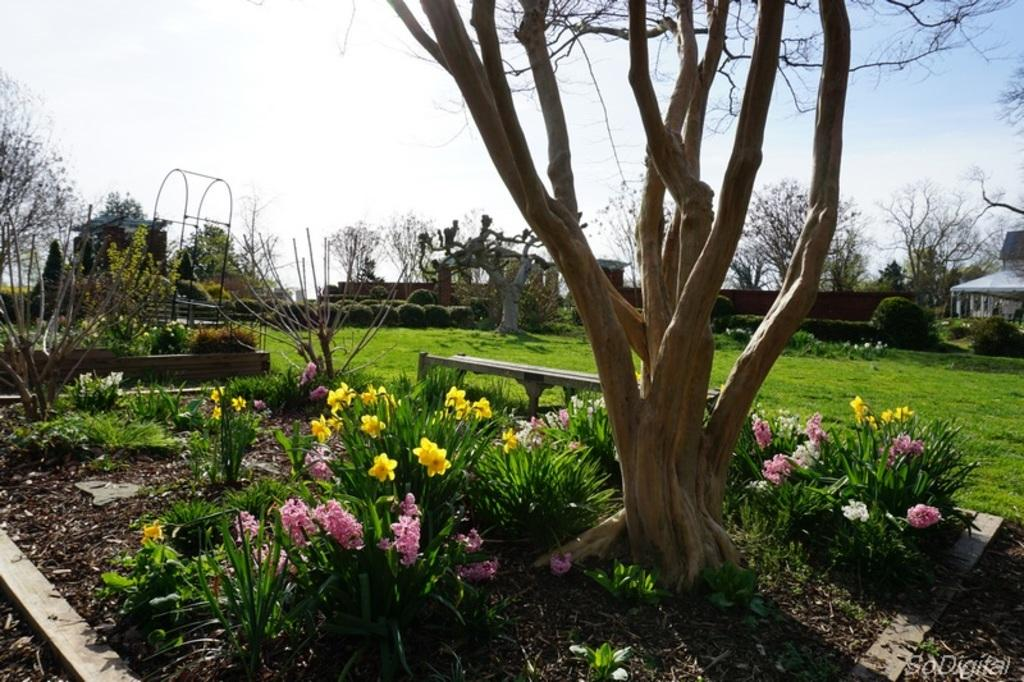What type of vegetation can be seen in the image? There are trees, plants, flowers, and bushes in the image. What structures are present in the image? There are sheds, stands, and benches in the image. What can be seen at the bottom of the image? There is some text at the bottom of the image. What is visible at the top of the image? The sky is visible at the top of the image. Can you tell me how many pigs are depicted in the image? There are no pigs present in the image. What type of quilt is draped over the bench in the image? There is no quilt present in the image. 